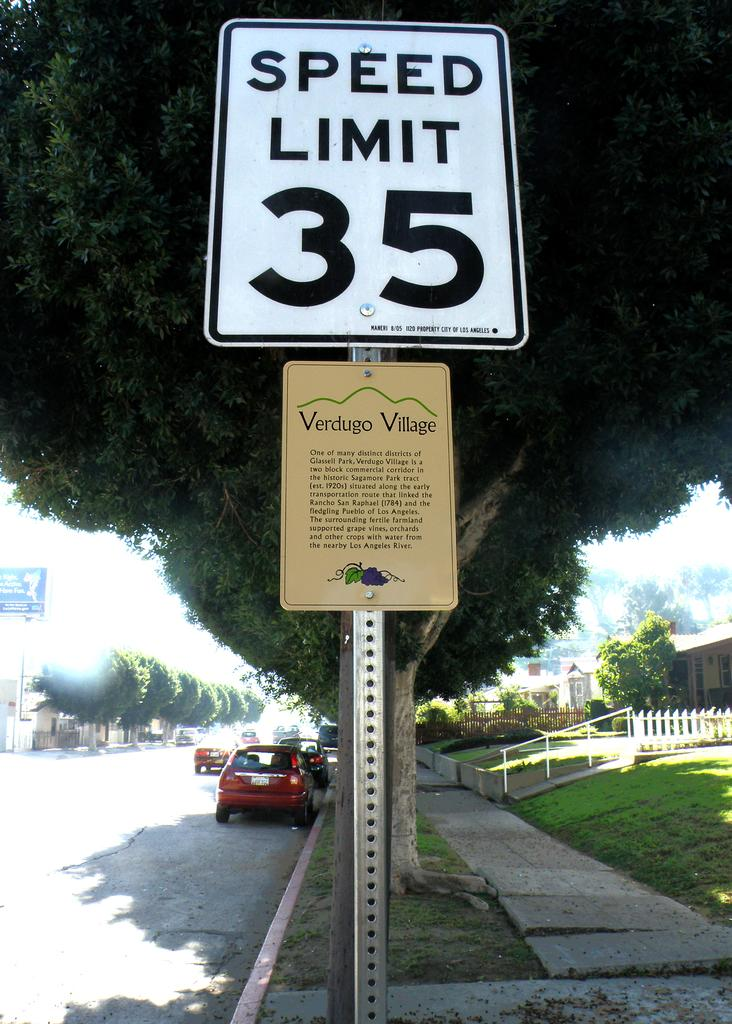<image>
Summarize the visual content of the image. A street sign for Verdugo Village shows a speed limit of 35 mph. 